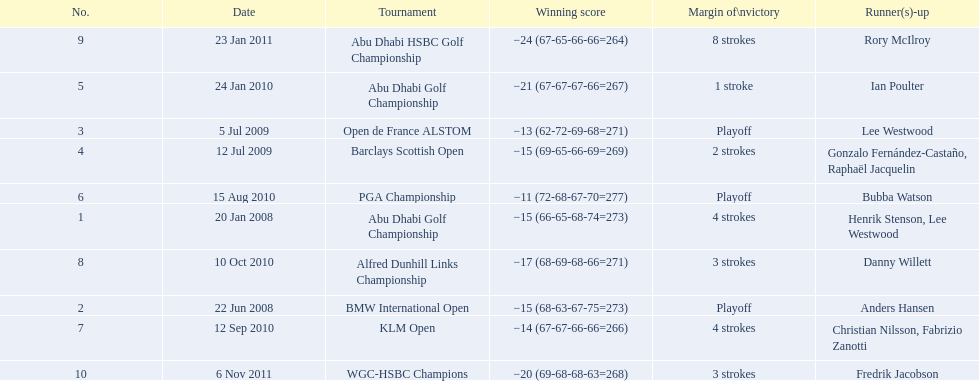What were the margins of victories of the tournaments? 4 strokes, Playoff, Playoff, 2 strokes, 1 stroke, Playoff, 4 strokes, 3 strokes, 8 strokes, 3 strokes. Of these, what was the margin of victory of the klm and the barklay 2 strokes, 4 strokes. What were the difference between these? 2 strokes. 